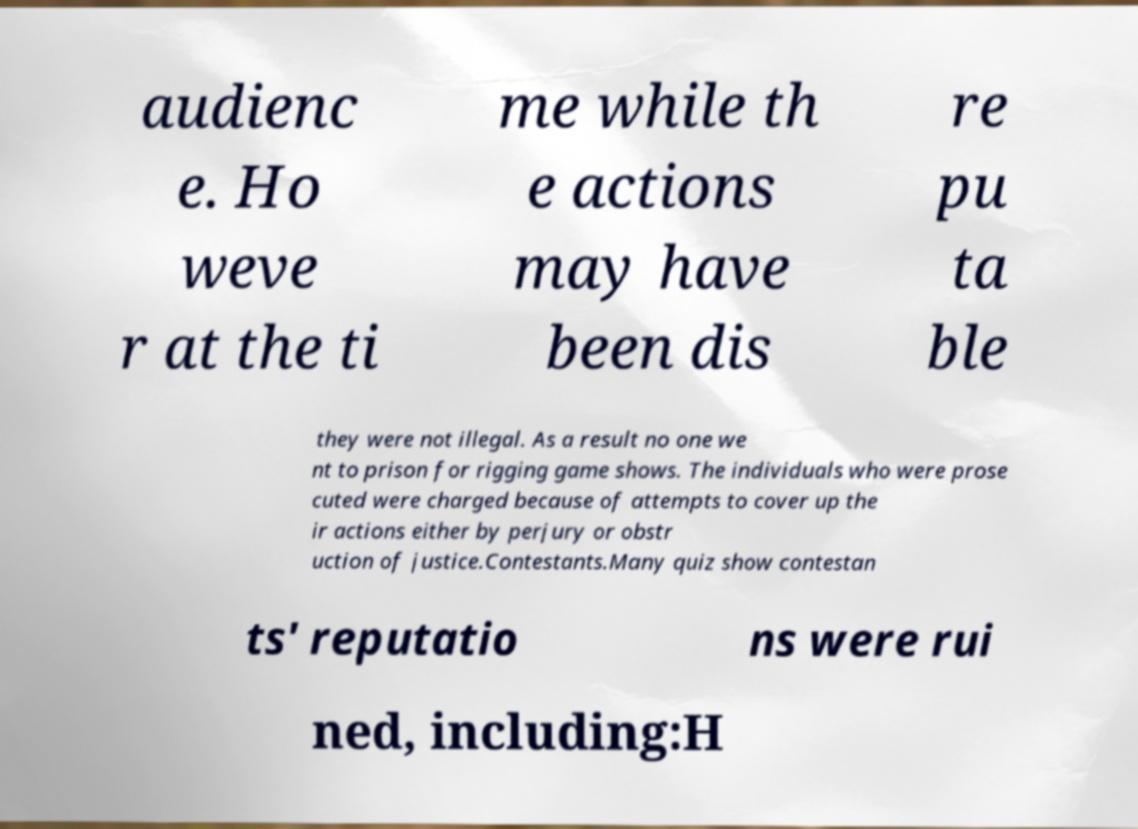Please identify and transcribe the text found in this image. audienc e. Ho weve r at the ti me while th e actions may have been dis re pu ta ble they were not illegal. As a result no one we nt to prison for rigging game shows. The individuals who were prose cuted were charged because of attempts to cover up the ir actions either by perjury or obstr uction of justice.Contestants.Many quiz show contestan ts' reputatio ns were rui ned, including:H 